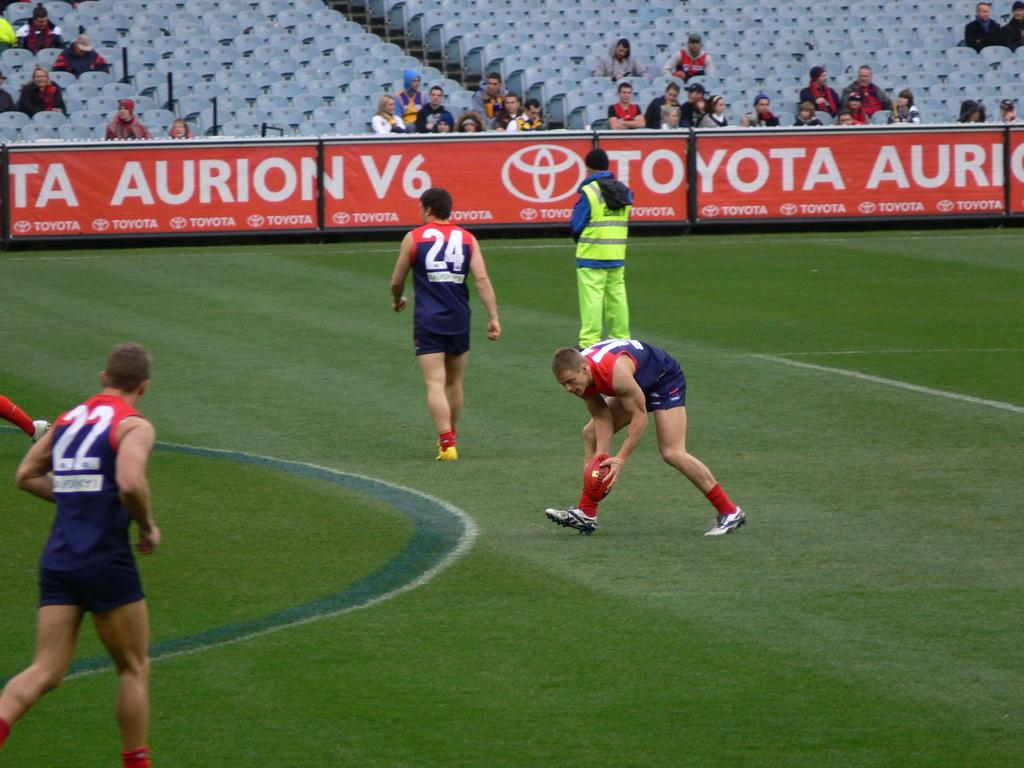<image>
Write a terse but informative summary of the picture. People are playing a game with a football on a field that is surrounded by a banner that says, 'Toyota Aurion V6'. 